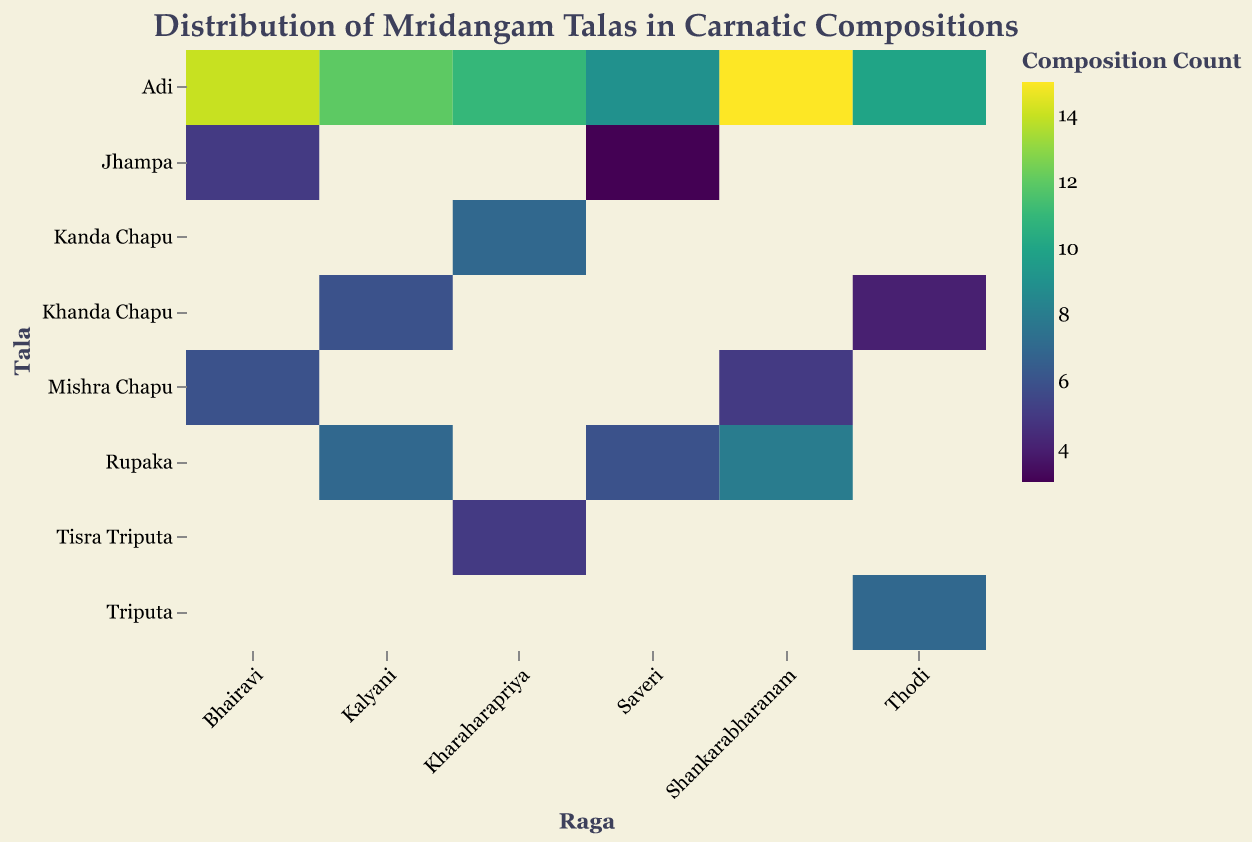what is the title of the heatmap? The title is usually found at the top of the heatmap and provides a summary of what the data visualization represents. In this case, the title is clear and indicates that the heatmap shows the distribution of mridangam talas in Carnatic compositions.
Answer: Distribution of Mridangam Talas in Carnatic Compositions Which Raga has the highest count for the Adi tala? By looking at the Adi row in the heatmap, we can find the cell with the highest color intensity (indicating the highest count), and then trace it back to the corresponding Raga on the x-axis.
Answer: Shankarabharanam What is the total count of compositions for the Raga Bhairavi across all talas? To find the total count, sum up the counts of all talas for the Raga Bhairavi. These counts are 14 (Adi), 6 (Mishra Chapu), and 5 (Jhampa). Adding them gives 14 + 6 + 5 = 25.
Answer: 25 Which tala is used only once for the Raga Saveri? Look at the counts for all talas in the Raga Saveri row. The tala with a count of 1 or close to the least occurrence is Jhampa with a count of 3.
Answer: Jhampa Between Kalyani and Thodi, which has more compositions in the Rupaka tala? Compare the counts for the Rupaka tala between the Ragas Kalyani (7) and Thodi (missing), indicating only Kalyani has compositions with the Rupaka tala.
Answer: Kalyani Which raga has the least diversity in terms of different talas used? The diversity can be judged by the number of different talas used for each raga. The raga using the least amount of unique talas is Bhairavi, which shows diversity in talas like Adi, Mishra Chapu, and Jhampa. Other ragas have different combinations of talas.
Answer: Bhairavi and others How many compositions use Khanda Chapu across all ragas? Sum up the counts of Khanda Chapu across all the rows (ragas). The total is 6 (Kalyani) + 4 (Thodi) + 7 (Kharaharapriya) = 17.
Answer: 17 Is there any tala not used for Kalyani? By examining the Kalyani row, we can see that it has counts for Adi, Rupaka, and Khanda Chapu. Talas like Mishra Chapu, Triputa, Jhampa, and Tisra Triputa are missing, implying they are not used.
Answer: Yes Which combination of raga and tala has the lowest count? Look for the cell with the least intensity in color, indicating the lowest count. Jhampa in Saveri has a count of 3, making it the lowest.
Answer: Saveri and Jhampa 